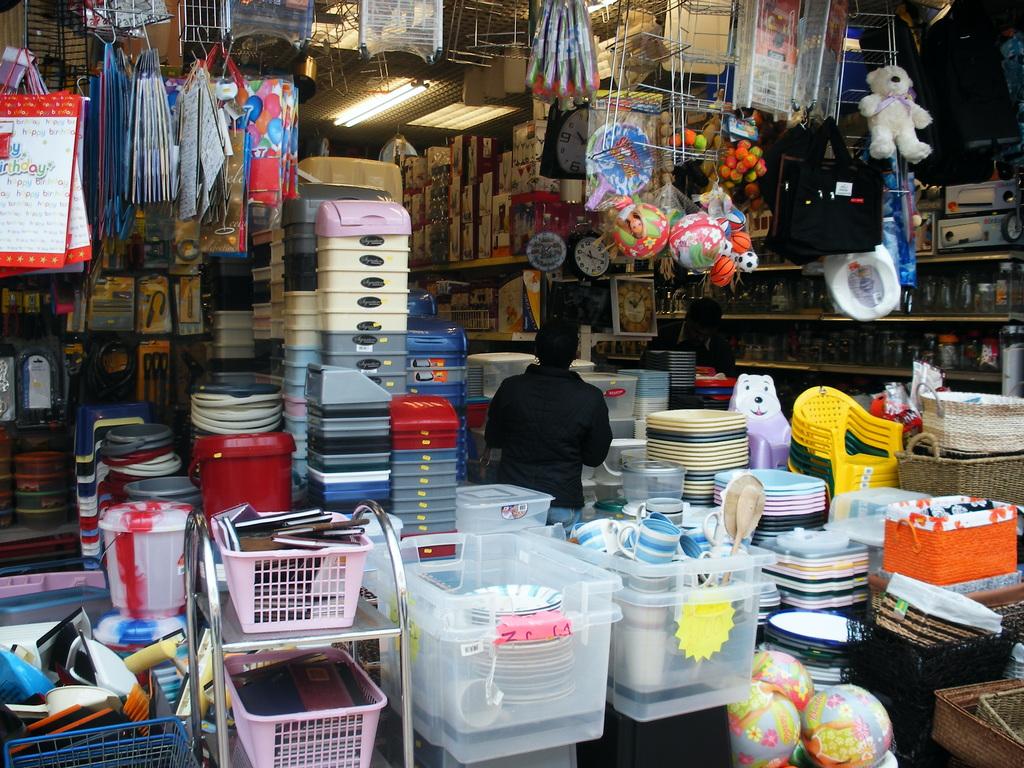Is this a store?>?
Give a very brief answer. Yes. 